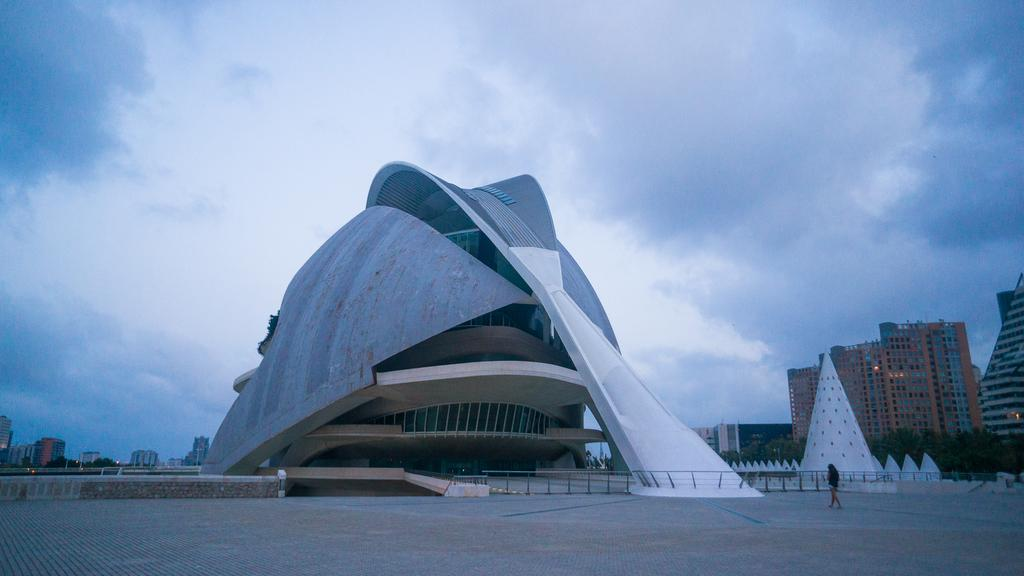What type of structures are visible in the image? There are buildings in the image. Can you describe the person in the image? There is a person on the ground in the image. What separates the buildings from the other objects in the image? There is a fence in the image. What other objects can be seen on the ground in the image? There are other objects on the ground in the image. What type of vegetation is present in the image? There are trees in the image. What can be seen in the background of the image? The sky is visible in the background of the image. What type of houses can be seen in the image? There is no mention of houses in the image; it features buildings. Can you tell me how many writers are present in the image? There is no writer present in the image. 